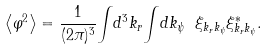<formula> <loc_0><loc_0><loc_500><loc_500>\left < \varphi ^ { 2 } \right > = \frac { 1 } { ( 2 \pi ) ^ { 3 } } { \int } d ^ { 3 } k _ { r } { \int } d k _ { \psi } \ \xi _ { k _ { r } k _ { \psi } } \xi ^ { * } _ { k _ { r } k _ { \psi } } .</formula> 